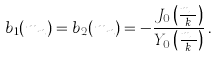<formula> <loc_0><loc_0><loc_500><loc_500>b _ { 1 } ( m _ { n } ) = b _ { 2 } ( m _ { n } ) = - \frac { J _ { 0 } \left ( \frac { m _ { n } } { k } \right ) } { Y _ { 0 } \left ( \frac { m _ { n } } { k } \right ) } \, .</formula> 